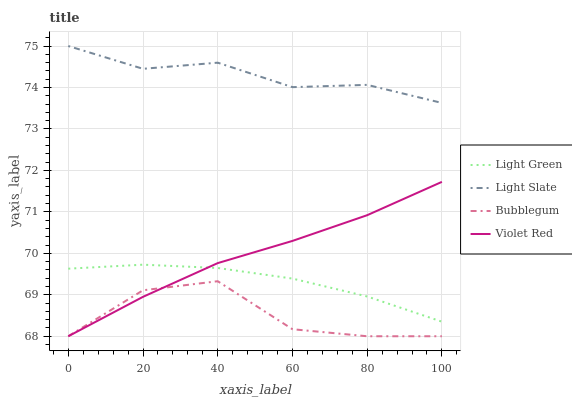Does Violet Red have the minimum area under the curve?
Answer yes or no. No. Does Violet Red have the maximum area under the curve?
Answer yes or no. No. Is Bubblegum the smoothest?
Answer yes or no. No. Is Violet Red the roughest?
Answer yes or no. No. Does Light Green have the lowest value?
Answer yes or no. No. Does Violet Red have the highest value?
Answer yes or no. No. Is Violet Red less than Light Slate?
Answer yes or no. Yes. Is Light Green greater than Bubblegum?
Answer yes or no. Yes. Does Violet Red intersect Light Slate?
Answer yes or no. No. 